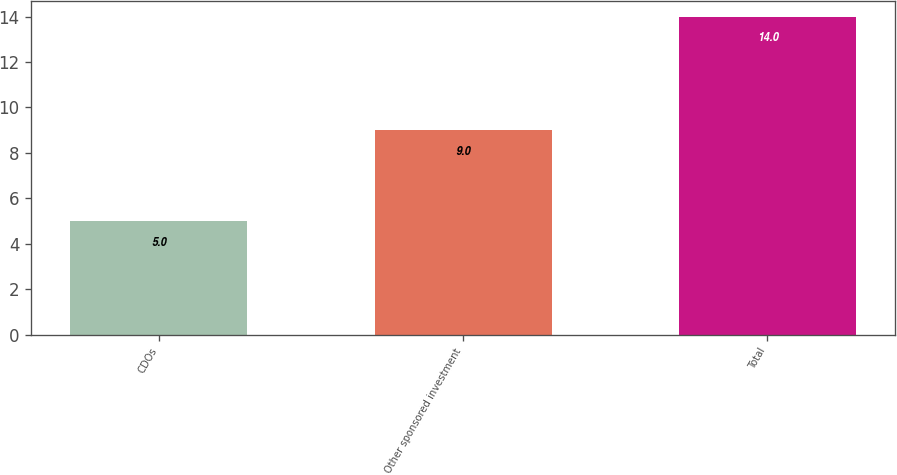Convert chart. <chart><loc_0><loc_0><loc_500><loc_500><bar_chart><fcel>CDOs<fcel>Other sponsored investment<fcel>Total<nl><fcel>5<fcel>9<fcel>14<nl></chart> 